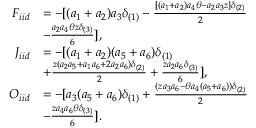Convert formula to latex. <formula><loc_0><loc_0><loc_500><loc_500>\begin{array} { r l } { F _ { i i d } } & { = - [ ( a _ { 1 } + a _ { 2 } ) a _ { 3 } \delta _ { ( 1 ) } - \frac { [ ( a _ { 1 } + a _ { 2 } ) a _ { 4 } \theta - a _ { 2 } a _ { 3 } z ] \delta _ { ( 2 ) } } { 2 } } \\ & { - \frac { a _ { 2 } a _ { 4 } \theta z \delta _ { ( 3 ) } } { 6 } ] , } \\ { J _ { i i d } } & { = - [ ( a _ { 1 } + a _ { 2 } ) ( a _ { 5 } + a _ { 6 } ) \delta _ { ( 1 ) } } \\ & { + \frac { z ( a _ { 2 } a _ { 5 } + a _ { 1 } a _ { 6 } + 2 a _ { 2 } a _ { 6 } ) \delta _ { ( 2 ) } } { 2 } + \frac { z a _ { 2 } a _ { 6 } \delta _ { ( 3 ) } } { 6 } ] , } \\ { O _ { i i d } } & { = - [ a _ { 3 } ( a _ { 5 } + a _ { 6 } ) \delta _ { ( 1 ) } + \frac { ( z a _ { 3 } a _ { 6 } - \theta a _ { 4 } ( a _ { 5 } + a _ { 6 } ) ) \delta _ { ( 2 ) } } { 2 } } \\ & { - \frac { z a _ { 4 } a _ { 6 } \theta \delta _ { ( 3 ) } } { 6 } ] . } \end{array}</formula> 